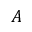Convert formula to latex. <formula><loc_0><loc_0><loc_500><loc_500>A</formula> 